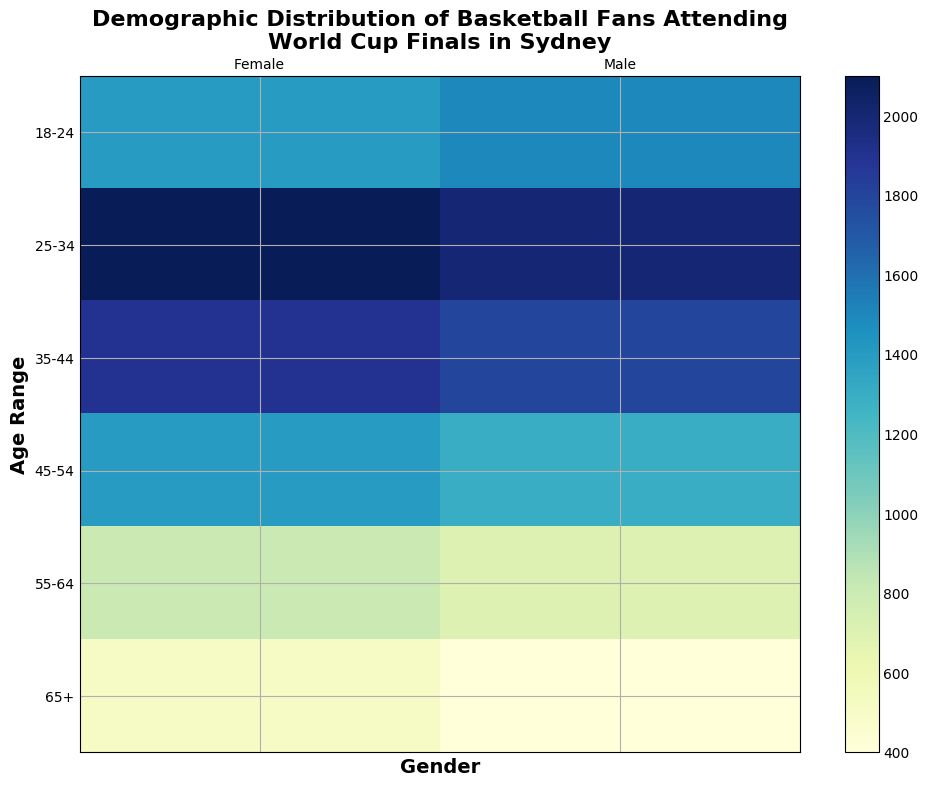What is the age range with the highest number of female fans? The age range with the highest number of female fans is the one with the darkest shade of green in the column labeled 'Female'. By observing the heatmap, the 25-34 age range has the darkest shade, indicating the highest number of female fans.
Answer: 25-34 Which age range has more male fans than female fans? To determine which age range has more male fans than female fans, compare the shades of green for each age range. The 18-24 and 35-44 age ranges have darker shades of green in the 'Male' column compared to the 'Female' column, indicating more male fans.
Answer: 18-24, 35-44 What is the total number of fans in the 45-54 age range? Sum the number of male and female fans in the 45-54 age range by adding the corresponding values from the heatmap. For males, there are 1300 fans, and for females, there are 1400 fans. Thus, the total is 1300 + 1400.
Answer: 2700 Which gender has more fans overall across all age ranges? To find out which gender has more fans overall, sum up the number of fans for each gender across all age ranges. Sum of males: 1500 + 2000 + 1800 + 1300 + 700 + 400 = 7700. Sum of females: 1400 + 2100 + 1900 + 1400 + 800 + 500 = 8100. Since 8100 is greater than 7700, females have more fans overall.
Answer: Female What is the difference in the number of fans between the 25-34 and 55-64 age ranges for both genders combined? Calculate the total number of fans for the 25-34 age range (2000 male + 2100 female = 4100) and for the 55-64 age range (700 male + 800 female = 1500). The difference is 4100 - 1500.
Answer: 2600 Which age range has the smallest gender disparity in fan numbers? Compare the difference in the number of fans between males and females for each age range. The age range with the smallest difference is the one with the most similar shade of green between the male and female columns. The 18-24 age range has the smallest disparity (1500 males - 1400 females = 100).
Answer: 18-24 What percentage of the total number of fans are in the 35-44 age range? Calculate the total number of fans in the 35-44 age range (1800 male + 1900 female = 3700) and the total number of all fans (7700 males + 8100 females = 15800). The percentage is (3700 / 15800) * 100.
Answer: 23.4% Which age range has the highest increase in the number of female fans compared to the previous age range? To find the highest increase in female fans, calculate the difference in the number of fans between consecutive age ranges and identify the maximum. Comparing the differences: 25-34 - 18-24 = 2100 - 1400 = 700, 35-44 - 25-34 = 1900 - 2100 = -200, 45-54 - 35-44 = 1400 - 1900 = -500, 55-64 - 45-54 = 800 - 1400 = -600, 65+ - 55-64 = 500 - 800 = -300. The highest increase is between 18-24 and 25-34.
Answer: 25-34 